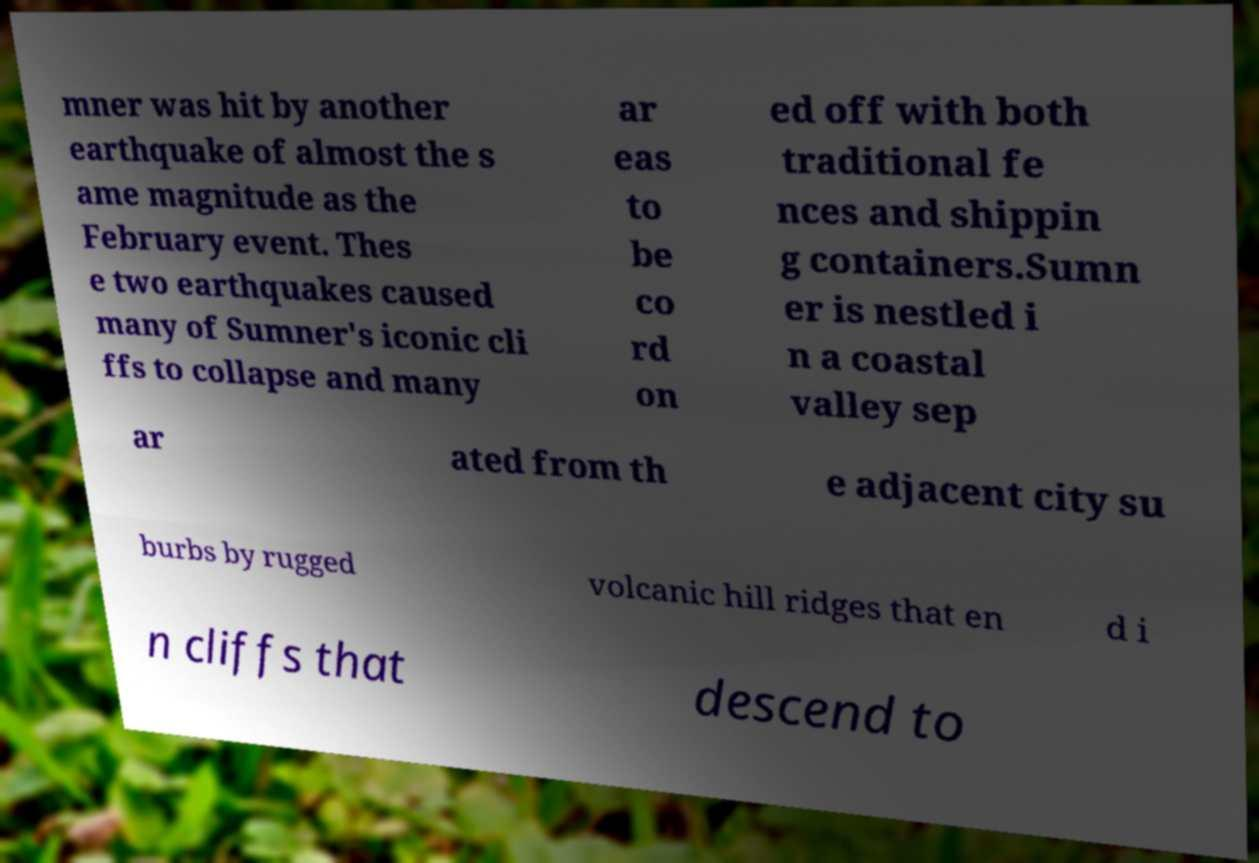There's text embedded in this image that I need extracted. Can you transcribe it verbatim? mner was hit by another earthquake of almost the s ame magnitude as the February event. Thes e two earthquakes caused many of Sumner's iconic cli ffs to collapse and many ar eas to be co rd on ed off with both traditional fe nces and shippin g containers.Sumn er is nestled i n a coastal valley sep ar ated from th e adjacent city su burbs by rugged volcanic hill ridges that en d i n cliffs that descend to 